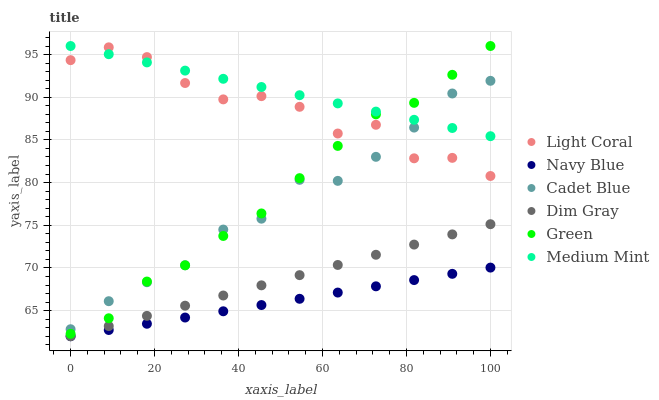Does Navy Blue have the minimum area under the curve?
Answer yes or no. Yes. Does Medium Mint have the maximum area under the curve?
Answer yes or no. Yes. Does Dim Gray have the minimum area under the curve?
Answer yes or no. No. Does Dim Gray have the maximum area under the curve?
Answer yes or no. No. Is Navy Blue the smoothest?
Answer yes or no. Yes. Is Light Coral the roughest?
Answer yes or no. Yes. Is Dim Gray the smoothest?
Answer yes or no. No. Is Dim Gray the roughest?
Answer yes or no. No. Does Dim Gray have the lowest value?
Answer yes or no. Yes. Does Light Coral have the lowest value?
Answer yes or no. No. Does Green have the highest value?
Answer yes or no. Yes. Does Dim Gray have the highest value?
Answer yes or no. No. Is Navy Blue less than Light Coral?
Answer yes or no. Yes. Is Medium Mint greater than Dim Gray?
Answer yes or no. Yes. Does Medium Mint intersect Green?
Answer yes or no. Yes. Is Medium Mint less than Green?
Answer yes or no. No. Is Medium Mint greater than Green?
Answer yes or no. No. Does Navy Blue intersect Light Coral?
Answer yes or no. No. 